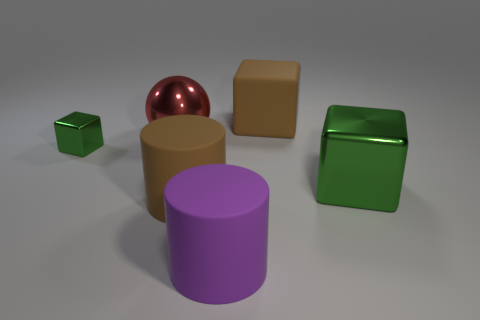Add 3 big green blocks. How many objects exist? 9 Subtract all spheres. How many objects are left? 5 Add 1 large cyan shiny objects. How many large cyan shiny objects exist? 1 Subtract 1 brown cubes. How many objects are left? 5 Subtract all tiny things. Subtract all big green things. How many objects are left? 4 Add 2 large red things. How many large red things are left? 3 